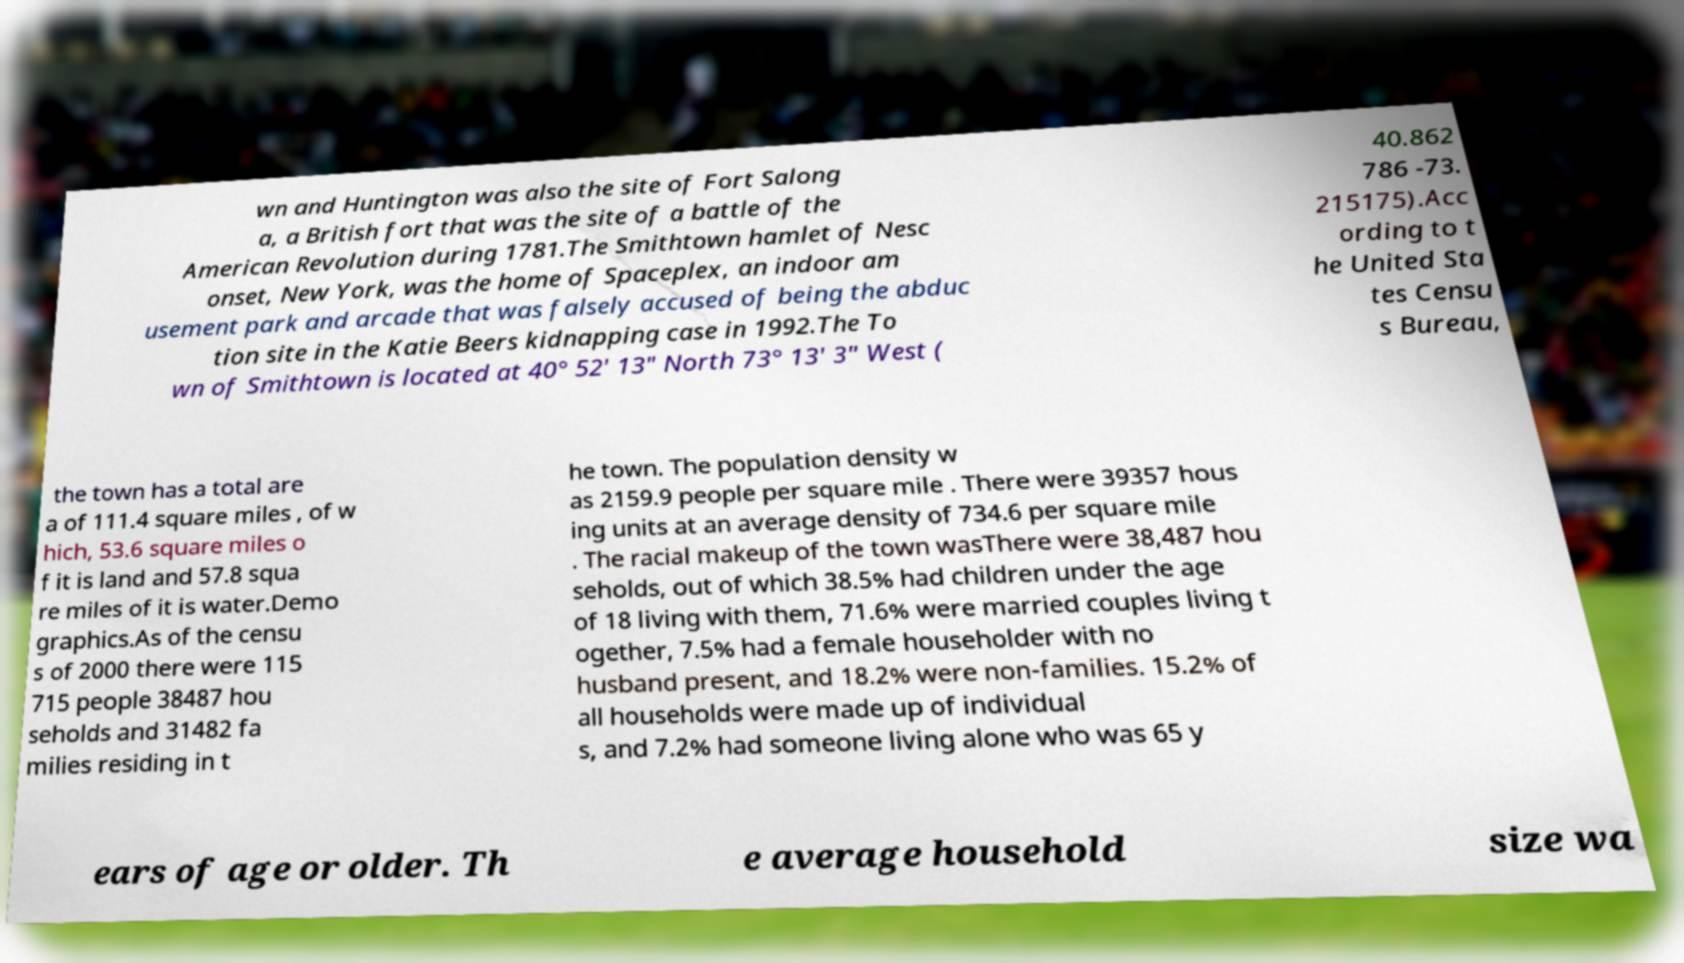Can you read and provide the text displayed in the image?This photo seems to have some interesting text. Can you extract and type it out for me? wn and Huntington was also the site of Fort Salong a, a British fort that was the site of a battle of the American Revolution during 1781.The Smithtown hamlet of Nesc onset, New York, was the home of Spaceplex, an indoor am usement park and arcade that was falsely accused of being the abduc tion site in the Katie Beers kidnapping case in 1992.The To wn of Smithtown is located at 40° 52' 13" North 73° 13' 3" West ( 40.862 786 -73. 215175).Acc ording to t he United Sta tes Censu s Bureau, the town has a total are a of 111.4 square miles , of w hich, 53.6 square miles o f it is land and 57.8 squa re miles of it is water.Demo graphics.As of the censu s of 2000 there were 115 715 people 38487 hou seholds and 31482 fa milies residing in t he town. The population density w as 2159.9 people per square mile . There were 39357 hous ing units at an average density of 734.6 per square mile . The racial makeup of the town wasThere were 38,487 hou seholds, out of which 38.5% had children under the age of 18 living with them, 71.6% were married couples living t ogether, 7.5% had a female householder with no husband present, and 18.2% were non-families. 15.2% of all households were made up of individual s, and 7.2% had someone living alone who was 65 y ears of age or older. Th e average household size wa 